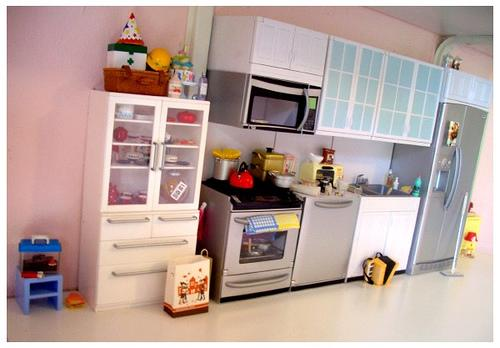What type of people obviously live here? kids 